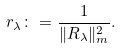<formula> <loc_0><loc_0><loc_500><loc_500>r _ { \lambda } \colon = \frac { 1 } { \| R _ { \lambda } \| ^ { 2 } _ { m } } .</formula> 